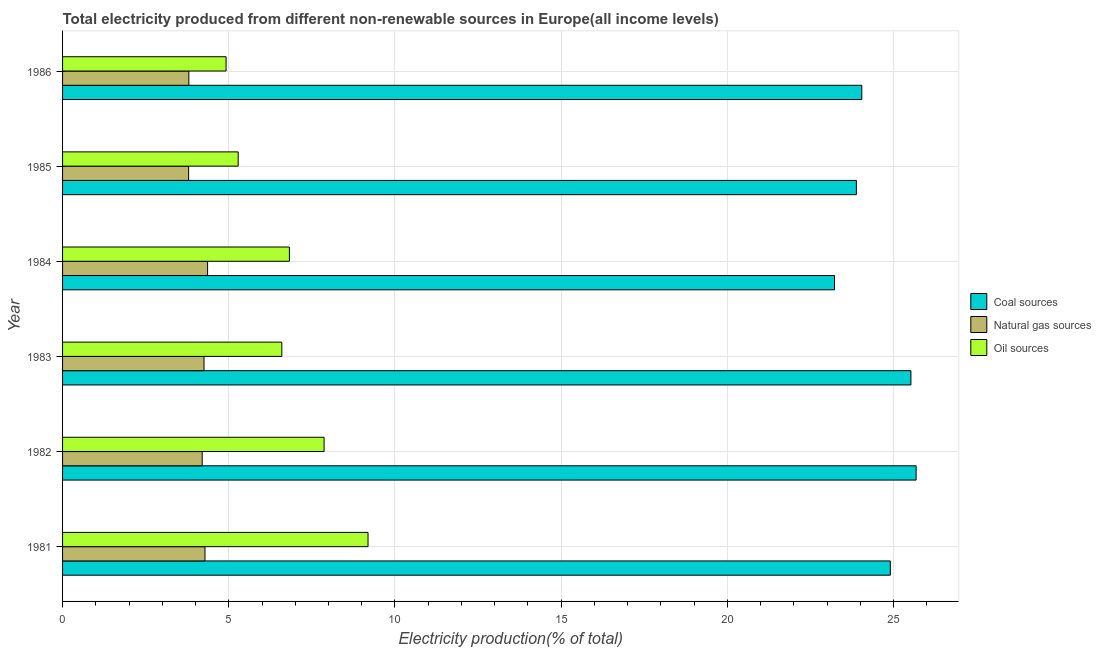Are the number of bars per tick equal to the number of legend labels?
Your answer should be very brief. Yes. How many bars are there on the 5th tick from the top?
Keep it short and to the point. 3. What is the label of the 4th group of bars from the top?
Your answer should be compact. 1983. In how many cases, is the number of bars for a given year not equal to the number of legend labels?
Give a very brief answer. 0. What is the percentage of electricity produced by oil sources in 1985?
Your answer should be very brief. 5.28. Across all years, what is the maximum percentage of electricity produced by oil sources?
Provide a short and direct response. 9.19. Across all years, what is the minimum percentage of electricity produced by natural gas?
Offer a terse response. 3.79. What is the total percentage of electricity produced by oil sources in the graph?
Your answer should be very brief. 40.68. What is the difference between the percentage of electricity produced by natural gas in 1981 and that in 1986?
Ensure brevity in your answer.  0.49. What is the difference between the percentage of electricity produced by natural gas in 1984 and the percentage of electricity produced by oil sources in 1982?
Offer a terse response. -3.5. What is the average percentage of electricity produced by natural gas per year?
Provide a short and direct response. 4.12. In the year 1985, what is the difference between the percentage of electricity produced by oil sources and percentage of electricity produced by coal?
Provide a succinct answer. -18.6. In how many years, is the percentage of electricity produced by coal greater than 17 %?
Your answer should be compact. 6. What is the ratio of the percentage of electricity produced by oil sources in 1981 to that in 1986?
Keep it short and to the point. 1.87. Is the difference between the percentage of electricity produced by coal in 1983 and 1984 greater than the difference between the percentage of electricity produced by natural gas in 1983 and 1984?
Give a very brief answer. Yes. What is the difference between the highest and the second highest percentage of electricity produced by oil sources?
Ensure brevity in your answer.  1.32. What is the difference between the highest and the lowest percentage of electricity produced by oil sources?
Your answer should be compact. 4.27. Is the sum of the percentage of electricity produced by coal in 1984 and 1986 greater than the maximum percentage of electricity produced by natural gas across all years?
Your answer should be compact. Yes. What does the 3rd bar from the top in 1985 represents?
Provide a succinct answer. Coal sources. What does the 3rd bar from the bottom in 1985 represents?
Ensure brevity in your answer.  Oil sources. Is it the case that in every year, the sum of the percentage of electricity produced by coal and percentage of electricity produced by natural gas is greater than the percentage of electricity produced by oil sources?
Offer a terse response. Yes. How many bars are there?
Offer a terse response. 18. What is the difference between two consecutive major ticks on the X-axis?
Give a very brief answer. 5. How many legend labels are there?
Make the answer very short. 3. How are the legend labels stacked?
Your answer should be very brief. Vertical. What is the title of the graph?
Offer a very short reply. Total electricity produced from different non-renewable sources in Europe(all income levels). What is the label or title of the X-axis?
Ensure brevity in your answer.  Electricity production(% of total). What is the Electricity production(% of total) of Coal sources in 1981?
Make the answer very short. 24.9. What is the Electricity production(% of total) of Natural gas sources in 1981?
Your answer should be very brief. 4.28. What is the Electricity production(% of total) of Oil sources in 1981?
Ensure brevity in your answer.  9.19. What is the Electricity production(% of total) of Coal sources in 1982?
Ensure brevity in your answer.  25.68. What is the Electricity production(% of total) of Natural gas sources in 1982?
Your response must be concise. 4.2. What is the Electricity production(% of total) in Oil sources in 1982?
Your answer should be very brief. 7.87. What is the Electricity production(% of total) in Coal sources in 1983?
Your answer should be compact. 25.52. What is the Electricity production(% of total) of Natural gas sources in 1983?
Your response must be concise. 4.26. What is the Electricity production(% of total) in Oil sources in 1983?
Provide a succinct answer. 6.6. What is the Electricity production(% of total) of Coal sources in 1984?
Ensure brevity in your answer.  23.22. What is the Electricity production(% of total) in Natural gas sources in 1984?
Provide a succinct answer. 4.36. What is the Electricity production(% of total) in Oil sources in 1984?
Your answer should be compact. 6.82. What is the Electricity production(% of total) of Coal sources in 1985?
Your response must be concise. 23.88. What is the Electricity production(% of total) in Natural gas sources in 1985?
Your response must be concise. 3.79. What is the Electricity production(% of total) in Oil sources in 1985?
Provide a succinct answer. 5.28. What is the Electricity production(% of total) in Coal sources in 1986?
Provide a succinct answer. 24.04. What is the Electricity production(% of total) in Natural gas sources in 1986?
Your response must be concise. 3.8. What is the Electricity production(% of total) of Oil sources in 1986?
Give a very brief answer. 4.92. Across all years, what is the maximum Electricity production(% of total) in Coal sources?
Ensure brevity in your answer.  25.68. Across all years, what is the maximum Electricity production(% of total) in Natural gas sources?
Offer a very short reply. 4.36. Across all years, what is the maximum Electricity production(% of total) in Oil sources?
Provide a succinct answer. 9.19. Across all years, what is the minimum Electricity production(% of total) in Coal sources?
Keep it short and to the point. 23.22. Across all years, what is the minimum Electricity production(% of total) of Natural gas sources?
Make the answer very short. 3.79. Across all years, what is the minimum Electricity production(% of total) in Oil sources?
Your response must be concise. 4.92. What is the total Electricity production(% of total) of Coal sources in the graph?
Offer a very short reply. 147.24. What is the total Electricity production(% of total) of Natural gas sources in the graph?
Your answer should be compact. 24.69. What is the total Electricity production(% of total) in Oil sources in the graph?
Keep it short and to the point. 40.68. What is the difference between the Electricity production(% of total) of Coal sources in 1981 and that in 1982?
Make the answer very short. -0.78. What is the difference between the Electricity production(% of total) of Natural gas sources in 1981 and that in 1982?
Offer a very short reply. 0.08. What is the difference between the Electricity production(% of total) of Oil sources in 1981 and that in 1982?
Keep it short and to the point. 1.32. What is the difference between the Electricity production(% of total) of Coal sources in 1981 and that in 1983?
Ensure brevity in your answer.  -0.62. What is the difference between the Electricity production(% of total) in Natural gas sources in 1981 and that in 1983?
Your answer should be very brief. 0.03. What is the difference between the Electricity production(% of total) of Oil sources in 1981 and that in 1983?
Offer a very short reply. 2.59. What is the difference between the Electricity production(% of total) of Coal sources in 1981 and that in 1984?
Provide a short and direct response. 1.68. What is the difference between the Electricity production(% of total) of Natural gas sources in 1981 and that in 1984?
Keep it short and to the point. -0.08. What is the difference between the Electricity production(% of total) of Oil sources in 1981 and that in 1984?
Ensure brevity in your answer.  2.36. What is the difference between the Electricity production(% of total) in Coal sources in 1981 and that in 1985?
Provide a short and direct response. 1.02. What is the difference between the Electricity production(% of total) in Natural gas sources in 1981 and that in 1985?
Make the answer very short. 0.49. What is the difference between the Electricity production(% of total) of Oil sources in 1981 and that in 1985?
Keep it short and to the point. 3.91. What is the difference between the Electricity production(% of total) of Coal sources in 1981 and that in 1986?
Ensure brevity in your answer.  0.86. What is the difference between the Electricity production(% of total) of Natural gas sources in 1981 and that in 1986?
Provide a succinct answer. 0.49. What is the difference between the Electricity production(% of total) of Oil sources in 1981 and that in 1986?
Offer a terse response. 4.27. What is the difference between the Electricity production(% of total) of Coal sources in 1982 and that in 1983?
Ensure brevity in your answer.  0.16. What is the difference between the Electricity production(% of total) of Natural gas sources in 1982 and that in 1983?
Make the answer very short. -0.06. What is the difference between the Electricity production(% of total) of Oil sources in 1982 and that in 1983?
Keep it short and to the point. 1.27. What is the difference between the Electricity production(% of total) of Coal sources in 1982 and that in 1984?
Provide a short and direct response. 2.45. What is the difference between the Electricity production(% of total) in Natural gas sources in 1982 and that in 1984?
Ensure brevity in your answer.  -0.16. What is the difference between the Electricity production(% of total) of Oil sources in 1982 and that in 1984?
Give a very brief answer. 1.04. What is the difference between the Electricity production(% of total) of Coal sources in 1982 and that in 1985?
Provide a short and direct response. 1.8. What is the difference between the Electricity production(% of total) of Natural gas sources in 1982 and that in 1985?
Your answer should be very brief. 0.41. What is the difference between the Electricity production(% of total) in Oil sources in 1982 and that in 1985?
Offer a terse response. 2.58. What is the difference between the Electricity production(% of total) in Coal sources in 1982 and that in 1986?
Ensure brevity in your answer.  1.63. What is the difference between the Electricity production(% of total) of Natural gas sources in 1982 and that in 1986?
Your answer should be very brief. 0.4. What is the difference between the Electricity production(% of total) of Oil sources in 1982 and that in 1986?
Your answer should be very brief. 2.95. What is the difference between the Electricity production(% of total) in Coal sources in 1983 and that in 1984?
Make the answer very short. 2.3. What is the difference between the Electricity production(% of total) of Natural gas sources in 1983 and that in 1984?
Make the answer very short. -0.11. What is the difference between the Electricity production(% of total) in Oil sources in 1983 and that in 1984?
Your response must be concise. -0.23. What is the difference between the Electricity production(% of total) in Coal sources in 1983 and that in 1985?
Keep it short and to the point. 1.64. What is the difference between the Electricity production(% of total) in Natural gas sources in 1983 and that in 1985?
Your answer should be very brief. 0.46. What is the difference between the Electricity production(% of total) of Oil sources in 1983 and that in 1985?
Provide a short and direct response. 1.31. What is the difference between the Electricity production(% of total) of Coal sources in 1983 and that in 1986?
Your response must be concise. 1.48. What is the difference between the Electricity production(% of total) of Natural gas sources in 1983 and that in 1986?
Your answer should be compact. 0.46. What is the difference between the Electricity production(% of total) of Oil sources in 1983 and that in 1986?
Your answer should be compact. 1.68. What is the difference between the Electricity production(% of total) of Coal sources in 1984 and that in 1985?
Offer a very short reply. -0.66. What is the difference between the Electricity production(% of total) in Natural gas sources in 1984 and that in 1985?
Offer a terse response. 0.57. What is the difference between the Electricity production(% of total) in Oil sources in 1984 and that in 1985?
Provide a succinct answer. 1.54. What is the difference between the Electricity production(% of total) of Coal sources in 1984 and that in 1986?
Keep it short and to the point. -0.82. What is the difference between the Electricity production(% of total) in Natural gas sources in 1984 and that in 1986?
Keep it short and to the point. 0.56. What is the difference between the Electricity production(% of total) of Oil sources in 1984 and that in 1986?
Provide a succinct answer. 1.91. What is the difference between the Electricity production(% of total) of Coal sources in 1985 and that in 1986?
Keep it short and to the point. -0.16. What is the difference between the Electricity production(% of total) in Natural gas sources in 1985 and that in 1986?
Your response must be concise. -0.01. What is the difference between the Electricity production(% of total) of Oil sources in 1985 and that in 1986?
Your answer should be compact. 0.36. What is the difference between the Electricity production(% of total) of Coal sources in 1981 and the Electricity production(% of total) of Natural gas sources in 1982?
Ensure brevity in your answer.  20.7. What is the difference between the Electricity production(% of total) in Coal sources in 1981 and the Electricity production(% of total) in Oil sources in 1982?
Provide a short and direct response. 17.03. What is the difference between the Electricity production(% of total) in Natural gas sources in 1981 and the Electricity production(% of total) in Oil sources in 1982?
Give a very brief answer. -3.58. What is the difference between the Electricity production(% of total) in Coal sources in 1981 and the Electricity production(% of total) in Natural gas sources in 1983?
Give a very brief answer. 20.65. What is the difference between the Electricity production(% of total) in Coal sources in 1981 and the Electricity production(% of total) in Oil sources in 1983?
Your answer should be compact. 18.3. What is the difference between the Electricity production(% of total) in Natural gas sources in 1981 and the Electricity production(% of total) in Oil sources in 1983?
Make the answer very short. -2.31. What is the difference between the Electricity production(% of total) of Coal sources in 1981 and the Electricity production(% of total) of Natural gas sources in 1984?
Your response must be concise. 20.54. What is the difference between the Electricity production(% of total) of Coal sources in 1981 and the Electricity production(% of total) of Oil sources in 1984?
Ensure brevity in your answer.  18.08. What is the difference between the Electricity production(% of total) of Natural gas sources in 1981 and the Electricity production(% of total) of Oil sources in 1984?
Your response must be concise. -2.54. What is the difference between the Electricity production(% of total) in Coal sources in 1981 and the Electricity production(% of total) in Natural gas sources in 1985?
Give a very brief answer. 21.11. What is the difference between the Electricity production(% of total) of Coal sources in 1981 and the Electricity production(% of total) of Oil sources in 1985?
Offer a very short reply. 19.62. What is the difference between the Electricity production(% of total) in Natural gas sources in 1981 and the Electricity production(% of total) in Oil sources in 1985?
Your response must be concise. -1. What is the difference between the Electricity production(% of total) of Coal sources in 1981 and the Electricity production(% of total) of Natural gas sources in 1986?
Provide a succinct answer. 21.1. What is the difference between the Electricity production(% of total) of Coal sources in 1981 and the Electricity production(% of total) of Oil sources in 1986?
Keep it short and to the point. 19.98. What is the difference between the Electricity production(% of total) in Natural gas sources in 1981 and the Electricity production(% of total) in Oil sources in 1986?
Your answer should be very brief. -0.63. What is the difference between the Electricity production(% of total) in Coal sources in 1982 and the Electricity production(% of total) in Natural gas sources in 1983?
Provide a short and direct response. 21.42. What is the difference between the Electricity production(% of total) in Coal sources in 1982 and the Electricity production(% of total) in Oil sources in 1983?
Provide a short and direct response. 19.08. What is the difference between the Electricity production(% of total) of Natural gas sources in 1982 and the Electricity production(% of total) of Oil sources in 1983?
Your response must be concise. -2.4. What is the difference between the Electricity production(% of total) of Coal sources in 1982 and the Electricity production(% of total) of Natural gas sources in 1984?
Provide a short and direct response. 21.31. What is the difference between the Electricity production(% of total) in Coal sources in 1982 and the Electricity production(% of total) in Oil sources in 1984?
Provide a short and direct response. 18.85. What is the difference between the Electricity production(% of total) of Natural gas sources in 1982 and the Electricity production(% of total) of Oil sources in 1984?
Offer a very short reply. -2.62. What is the difference between the Electricity production(% of total) in Coal sources in 1982 and the Electricity production(% of total) in Natural gas sources in 1985?
Make the answer very short. 21.88. What is the difference between the Electricity production(% of total) of Coal sources in 1982 and the Electricity production(% of total) of Oil sources in 1985?
Ensure brevity in your answer.  20.39. What is the difference between the Electricity production(% of total) of Natural gas sources in 1982 and the Electricity production(% of total) of Oil sources in 1985?
Offer a terse response. -1.08. What is the difference between the Electricity production(% of total) of Coal sources in 1982 and the Electricity production(% of total) of Natural gas sources in 1986?
Your answer should be very brief. 21.88. What is the difference between the Electricity production(% of total) of Coal sources in 1982 and the Electricity production(% of total) of Oil sources in 1986?
Keep it short and to the point. 20.76. What is the difference between the Electricity production(% of total) of Natural gas sources in 1982 and the Electricity production(% of total) of Oil sources in 1986?
Your answer should be very brief. -0.72. What is the difference between the Electricity production(% of total) in Coal sources in 1983 and the Electricity production(% of total) in Natural gas sources in 1984?
Make the answer very short. 21.16. What is the difference between the Electricity production(% of total) of Coal sources in 1983 and the Electricity production(% of total) of Oil sources in 1984?
Make the answer very short. 18.7. What is the difference between the Electricity production(% of total) of Natural gas sources in 1983 and the Electricity production(% of total) of Oil sources in 1984?
Give a very brief answer. -2.57. What is the difference between the Electricity production(% of total) of Coal sources in 1983 and the Electricity production(% of total) of Natural gas sources in 1985?
Keep it short and to the point. 21.73. What is the difference between the Electricity production(% of total) of Coal sources in 1983 and the Electricity production(% of total) of Oil sources in 1985?
Keep it short and to the point. 20.24. What is the difference between the Electricity production(% of total) of Natural gas sources in 1983 and the Electricity production(% of total) of Oil sources in 1985?
Provide a short and direct response. -1.03. What is the difference between the Electricity production(% of total) of Coal sources in 1983 and the Electricity production(% of total) of Natural gas sources in 1986?
Your answer should be very brief. 21.72. What is the difference between the Electricity production(% of total) of Coal sources in 1983 and the Electricity production(% of total) of Oil sources in 1986?
Offer a terse response. 20.6. What is the difference between the Electricity production(% of total) in Natural gas sources in 1983 and the Electricity production(% of total) in Oil sources in 1986?
Provide a succinct answer. -0.66. What is the difference between the Electricity production(% of total) in Coal sources in 1984 and the Electricity production(% of total) in Natural gas sources in 1985?
Provide a succinct answer. 19.43. What is the difference between the Electricity production(% of total) in Coal sources in 1984 and the Electricity production(% of total) in Oil sources in 1985?
Your response must be concise. 17.94. What is the difference between the Electricity production(% of total) in Natural gas sources in 1984 and the Electricity production(% of total) in Oil sources in 1985?
Ensure brevity in your answer.  -0.92. What is the difference between the Electricity production(% of total) in Coal sources in 1984 and the Electricity production(% of total) in Natural gas sources in 1986?
Give a very brief answer. 19.42. What is the difference between the Electricity production(% of total) in Coal sources in 1984 and the Electricity production(% of total) in Oil sources in 1986?
Provide a short and direct response. 18.3. What is the difference between the Electricity production(% of total) in Natural gas sources in 1984 and the Electricity production(% of total) in Oil sources in 1986?
Give a very brief answer. -0.56. What is the difference between the Electricity production(% of total) in Coal sources in 1985 and the Electricity production(% of total) in Natural gas sources in 1986?
Keep it short and to the point. 20.08. What is the difference between the Electricity production(% of total) of Coal sources in 1985 and the Electricity production(% of total) of Oil sources in 1986?
Your response must be concise. 18.96. What is the difference between the Electricity production(% of total) in Natural gas sources in 1985 and the Electricity production(% of total) in Oil sources in 1986?
Your response must be concise. -1.13. What is the average Electricity production(% of total) of Coal sources per year?
Offer a very short reply. 24.54. What is the average Electricity production(% of total) in Natural gas sources per year?
Offer a very short reply. 4.12. What is the average Electricity production(% of total) in Oil sources per year?
Provide a succinct answer. 6.78. In the year 1981, what is the difference between the Electricity production(% of total) in Coal sources and Electricity production(% of total) in Natural gas sources?
Your answer should be compact. 20.62. In the year 1981, what is the difference between the Electricity production(% of total) in Coal sources and Electricity production(% of total) in Oil sources?
Your response must be concise. 15.71. In the year 1981, what is the difference between the Electricity production(% of total) of Natural gas sources and Electricity production(% of total) of Oil sources?
Provide a succinct answer. -4.9. In the year 1982, what is the difference between the Electricity production(% of total) of Coal sources and Electricity production(% of total) of Natural gas sources?
Provide a succinct answer. 21.48. In the year 1982, what is the difference between the Electricity production(% of total) in Coal sources and Electricity production(% of total) in Oil sources?
Your answer should be compact. 17.81. In the year 1982, what is the difference between the Electricity production(% of total) in Natural gas sources and Electricity production(% of total) in Oil sources?
Offer a very short reply. -3.67. In the year 1983, what is the difference between the Electricity production(% of total) of Coal sources and Electricity production(% of total) of Natural gas sources?
Ensure brevity in your answer.  21.27. In the year 1983, what is the difference between the Electricity production(% of total) of Coal sources and Electricity production(% of total) of Oil sources?
Offer a very short reply. 18.92. In the year 1983, what is the difference between the Electricity production(% of total) of Natural gas sources and Electricity production(% of total) of Oil sources?
Your response must be concise. -2.34. In the year 1984, what is the difference between the Electricity production(% of total) in Coal sources and Electricity production(% of total) in Natural gas sources?
Offer a terse response. 18.86. In the year 1984, what is the difference between the Electricity production(% of total) in Coal sources and Electricity production(% of total) in Oil sources?
Offer a terse response. 16.4. In the year 1984, what is the difference between the Electricity production(% of total) of Natural gas sources and Electricity production(% of total) of Oil sources?
Provide a succinct answer. -2.46. In the year 1985, what is the difference between the Electricity production(% of total) in Coal sources and Electricity production(% of total) in Natural gas sources?
Provide a succinct answer. 20.09. In the year 1985, what is the difference between the Electricity production(% of total) of Coal sources and Electricity production(% of total) of Oil sources?
Provide a short and direct response. 18.6. In the year 1985, what is the difference between the Electricity production(% of total) of Natural gas sources and Electricity production(% of total) of Oil sources?
Provide a short and direct response. -1.49. In the year 1986, what is the difference between the Electricity production(% of total) in Coal sources and Electricity production(% of total) in Natural gas sources?
Keep it short and to the point. 20.24. In the year 1986, what is the difference between the Electricity production(% of total) of Coal sources and Electricity production(% of total) of Oil sources?
Your response must be concise. 19.12. In the year 1986, what is the difference between the Electricity production(% of total) of Natural gas sources and Electricity production(% of total) of Oil sources?
Provide a short and direct response. -1.12. What is the ratio of the Electricity production(% of total) in Coal sources in 1981 to that in 1982?
Keep it short and to the point. 0.97. What is the ratio of the Electricity production(% of total) in Natural gas sources in 1981 to that in 1982?
Provide a succinct answer. 1.02. What is the ratio of the Electricity production(% of total) of Oil sources in 1981 to that in 1982?
Offer a terse response. 1.17. What is the ratio of the Electricity production(% of total) in Coal sources in 1981 to that in 1983?
Your response must be concise. 0.98. What is the ratio of the Electricity production(% of total) of Oil sources in 1981 to that in 1983?
Keep it short and to the point. 1.39. What is the ratio of the Electricity production(% of total) of Coal sources in 1981 to that in 1984?
Your answer should be very brief. 1.07. What is the ratio of the Electricity production(% of total) of Natural gas sources in 1981 to that in 1984?
Your answer should be compact. 0.98. What is the ratio of the Electricity production(% of total) in Oil sources in 1981 to that in 1984?
Offer a terse response. 1.35. What is the ratio of the Electricity production(% of total) of Coal sources in 1981 to that in 1985?
Offer a terse response. 1.04. What is the ratio of the Electricity production(% of total) in Natural gas sources in 1981 to that in 1985?
Provide a succinct answer. 1.13. What is the ratio of the Electricity production(% of total) in Oil sources in 1981 to that in 1985?
Offer a terse response. 1.74. What is the ratio of the Electricity production(% of total) of Coal sources in 1981 to that in 1986?
Offer a terse response. 1.04. What is the ratio of the Electricity production(% of total) in Natural gas sources in 1981 to that in 1986?
Your answer should be compact. 1.13. What is the ratio of the Electricity production(% of total) of Oil sources in 1981 to that in 1986?
Keep it short and to the point. 1.87. What is the ratio of the Electricity production(% of total) of Coal sources in 1982 to that in 1983?
Offer a terse response. 1.01. What is the ratio of the Electricity production(% of total) in Natural gas sources in 1982 to that in 1983?
Your answer should be very brief. 0.99. What is the ratio of the Electricity production(% of total) of Oil sources in 1982 to that in 1983?
Offer a very short reply. 1.19. What is the ratio of the Electricity production(% of total) in Coal sources in 1982 to that in 1984?
Give a very brief answer. 1.11. What is the ratio of the Electricity production(% of total) of Natural gas sources in 1982 to that in 1984?
Offer a terse response. 0.96. What is the ratio of the Electricity production(% of total) in Oil sources in 1982 to that in 1984?
Keep it short and to the point. 1.15. What is the ratio of the Electricity production(% of total) of Coal sources in 1982 to that in 1985?
Your response must be concise. 1.08. What is the ratio of the Electricity production(% of total) of Natural gas sources in 1982 to that in 1985?
Offer a very short reply. 1.11. What is the ratio of the Electricity production(% of total) in Oil sources in 1982 to that in 1985?
Your answer should be compact. 1.49. What is the ratio of the Electricity production(% of total) in Coal sources in 1982 to that in 1986?
Provide a short and direct response. 1.07. What is the ratio of the Electricity production(% of total) of Natural gas sources in 1982 to that in 1986?
Ensure brevity in your answer.  1.11. What is the ratio of the Electricity production(% of total) of Oil sources in 1982 to that in 1986?
Your answer should be very brief. 1.6. What is the ratio of the Electricity production(% of total) of Coal sources in 1983 to that in 1984?
Give a very brief answer. 1.1. What is the ratio of the Electricity production(% of total) in Natural gas sources in 1983 to that in 1984?
Give a very brief answer. 0.98. What is the ratio of the Electricity production(% of total) of Oil sources in 1983 to that in 1984?
Your answer should be very brief. 0.97. What is the ratio of the Electricity production(% of total) of Coal sources in 1983 to that in 1985?
Make the answer very short. 1.07. What is the ratio of the Electricity production(% of total) in Natural gas sources in 1983 to that in 1985?
Give a very brief answer. 1.12. What is the ratio of the Electricity production(% of total) of Oil sources in 1983 to that in 1985?
Make the answer very short. 1.25. What is the ratio of the Electricity production(% of total) of Coal sources in 1983 to that in 1986?
Offer a terse response. 1.06. What is the ratio of the Electricity production(% of total) of Natural gas sources in 1983 to that in 1986?
Make the answer very short. 1.12. What is the ratio of the Electricity production(% of total) in Oil sources in 1983 to that in 1986?
Provide a short and direct response. 1.34. What is the ratio of the Electricity production(% of total) in Coal sources in 1984 to that in 1985?
Provide a succinct answer. 0.97. What is the ratio of the Electricity production(% of total) of Natural gas sources in 1984 to that in 1985?
Your answer should be very brief. 1.15. What is the ratio of the Electricity production(% of total) of Oil sources in 1984 to that in 1985?
Your answer should be compact. 1.29. What is the ratio of the Electricity production(% of total) of Coal sources in 1984 to that in 1986?
Offer a terse response. 0.97. What is the ratio of the Electricity production(% of total) of Natural gas sources in 1984 to that in 1986?
Make the answer very short. 1.15. What is the ratio of the Electricity production(% of total) of Oil sources in 1984 to that in 1986?
Your response must be concise. 1.39. What is the ratio of the Electricity production(% of total) in Coal sources in 1985 to that in 1986?
Give a very brief answer. 0.99. What is the ratio of the Electricity production(% of total) of Natural gas sources in 1985 to that in 1986?
Offer a very short reply. 1. What is the ratio of the Electricity production(% of total) of Oil sources in 1985 to that in 1986?
Your response must be concise. 1.07. What is the difference between the highest and the second highest Electricity production(% of total) of Coal sources?
Your response must be concise. 0.16. What is the difference between the highest and the second highest Electricity production(% of total) in Natural gas sources?
Make the answer very short. 0.08. What is the difference between the highest and the second highest Electricity production(% of total) of Oil sources?
Provide a short and direct response. 1.32. What is the difference between the highest and the lowest Electricity production(% of total) of Coal sources?
Make the answer very short. 2.45. What is the difference between the highest and the lowest Electricity production(% of total) of Natural gas sources?
Offer a terse response. 0.57. What is the difference between the highest and the lowest Electricity production(% of total) of Oil sources?
Make the answer very short. 4.27. 